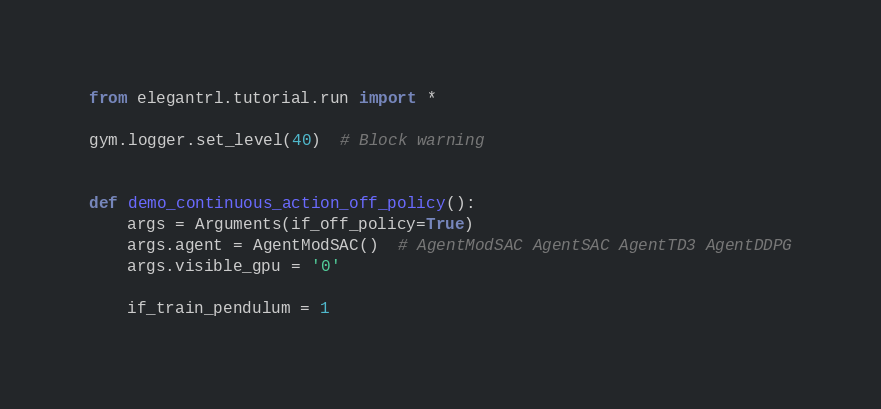Convert code to text. <code><loc_0><loc_0><loc_500><loc_500><_Python_>from elegantrl.tutorial.run import *

gym.logger.set_level(40)  # Block warning


def demo_continuous_action_off_policy():
    args = Arguments(if_off_policy=True)
    args.agent = AgentModSAC()  # AgentModSAC AgentSAC AgentTD3 AgentDDPG
    args.visible_gpu = '0'

    if_train_pendulum = 1</code> 